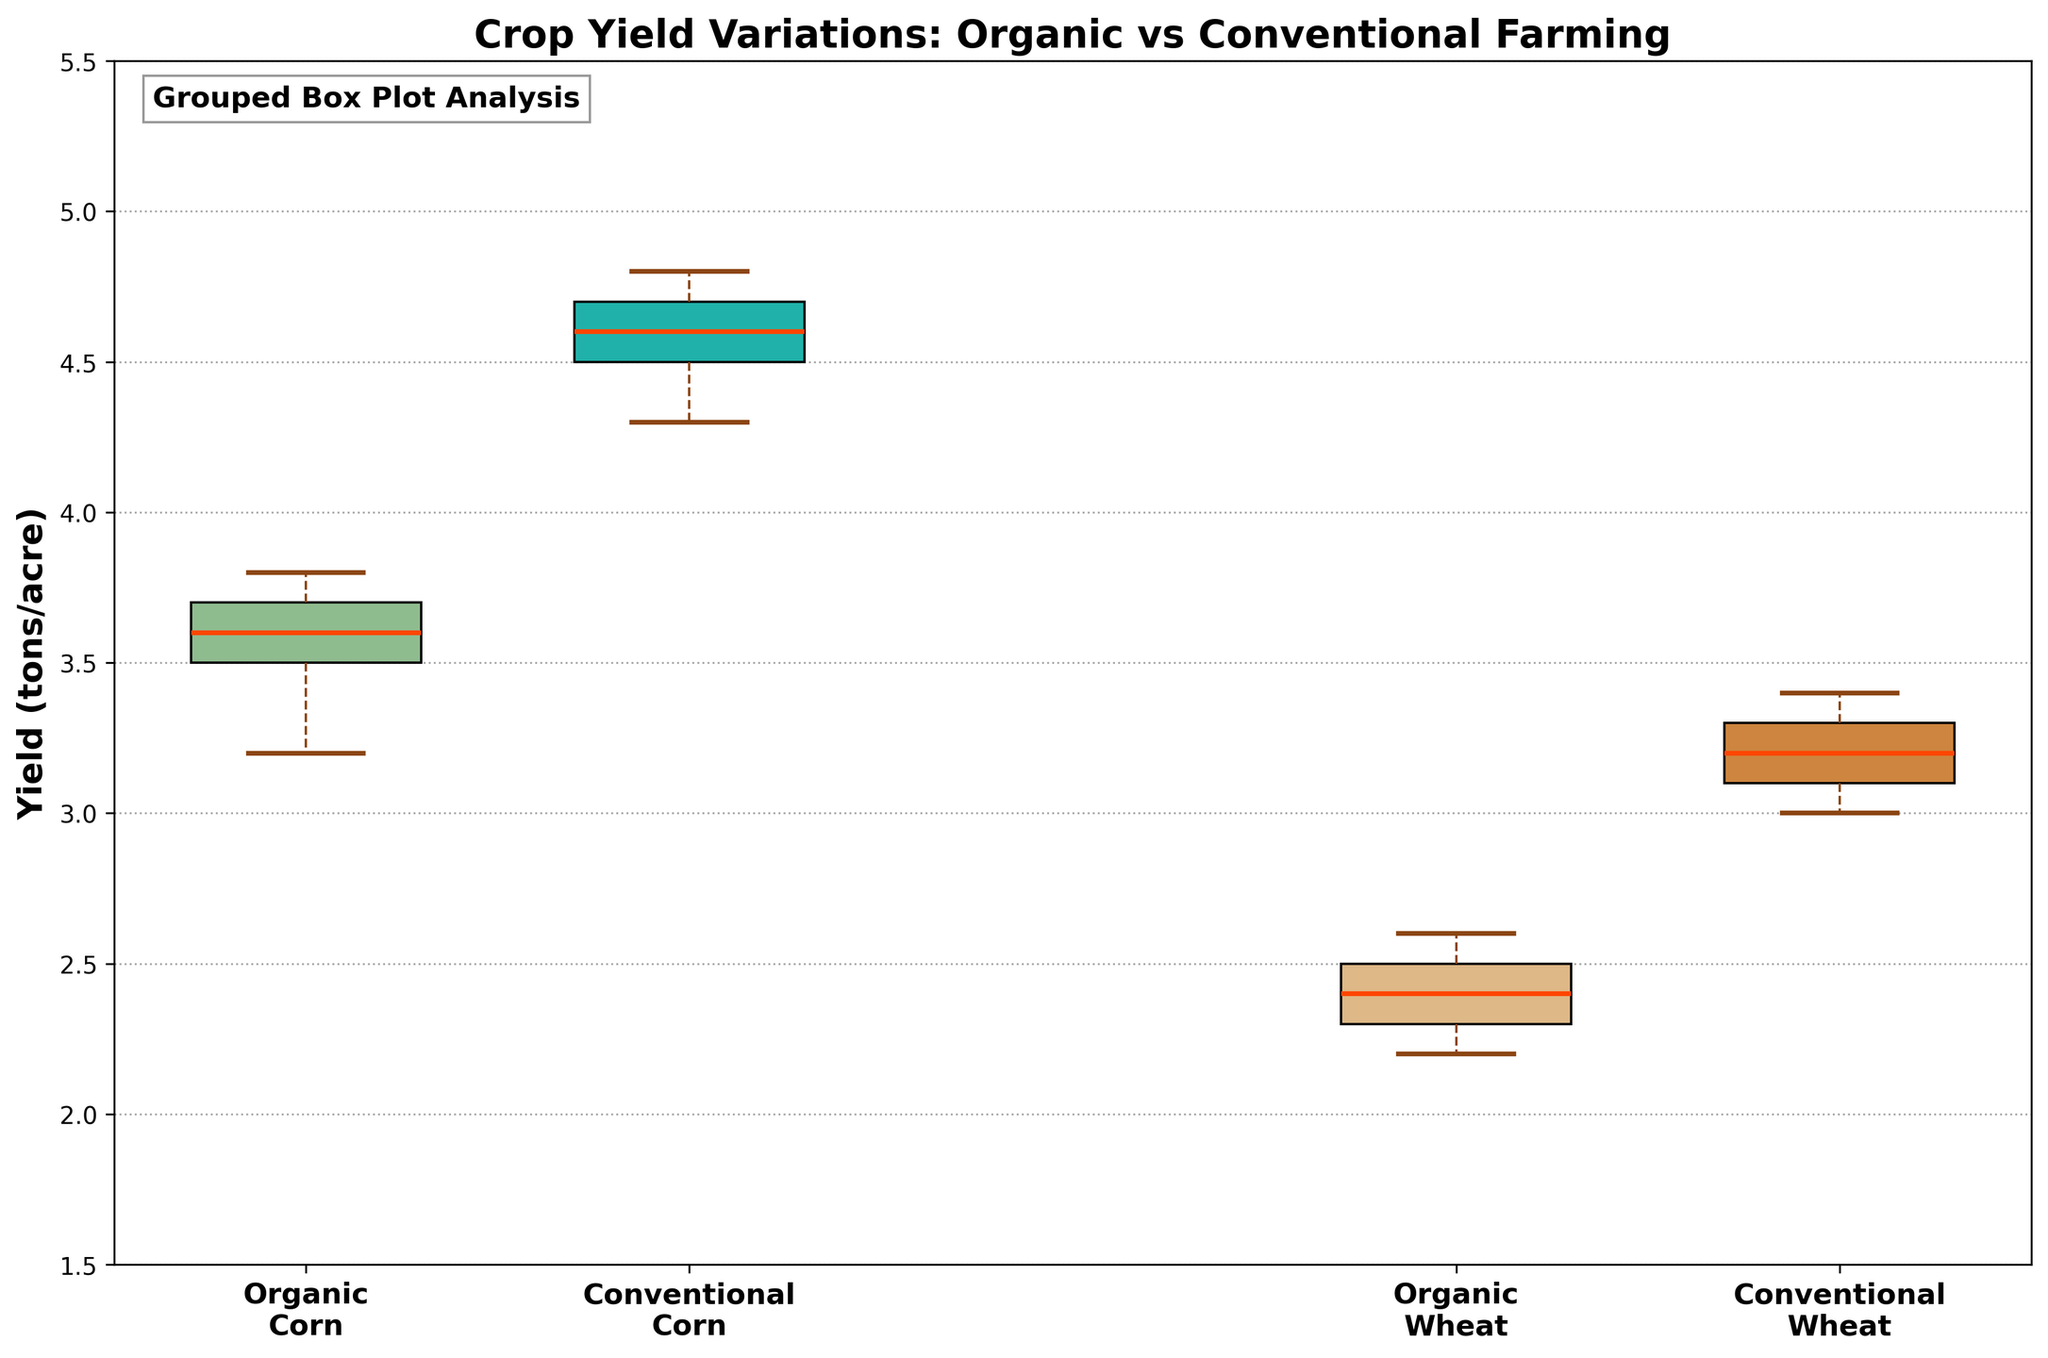What is the title of the plot? The title of the plot is often found at the top of the figure, providing a summary of the visualized data. In this case, the title says, "Crop Yield Variations: Organic vs Conventional Farming".
Answer: Crop Yield Variations: Organic vs Conventional Farming Which farming practice shows a higher median yield for Corn? To determine which farming practice has a higher median yield for Corn, look at the position of the median line within the box plots for "Organic Corn" and "Conventional Corn". The median line for Conventional Corn is higher than that for Organic Corn, indicating a higher yield.
Answer: Conventional What are the labels for the x-axis categories? The x-axis categories are labeled with the types of crops and the farming practices. The labels are 'Organic Corn', 'Conventional Corn', 'Organic Wheat', and 'Conventional Wheat'.
Answer: Organic Corn, Conventional Corn, Organic Wheat, Conventional Wheat Which crop and practice combination has the lowest yield value? To find the lowest yield value, check the lower end of the whiskers for each box plot. The lowest value occurs for Organic Wheat, as its whisker extends to the lowest point on the yield axis.
Answer: Organic Wheat Is there a difference in median yield between Organic Wheat and Conventional Wheat, and if so, how much? The median yield for Organic Wheat can be seen as the horizontal line inside the Organic Wheat box, and similarly for Conventional Wheat. By comparing these positions, the difference between the median yields of Organic and Conventional Wheat can be observed as approximately 1.0 tons/acre, given Organic Wheat's median is around 2.4 while Conventional Wheat's median is around 3.4.
Answer: 1.0 tons/acre Which group, among the four categories, shows the greatest range in yield values? The range of each group is the difference between the top of the upper whisker and the bottom of the lower whisker. By visually comparing these, Conventional Corn shows the greatest range as its whiskers span the largest distance on the y-axis.
Answer: Conventional Corn How does the consistency of yield for Organic Corn compare to Conventional Corn? Consistency can be assessed by looking at the interquartile range (IQR) which is represented by the height of the box. Organic Corn has a smaller IQR compared to Conventional Corn, indicating that Organic Corn yields are more consistent.
Answer: More consistent What patches colors are used to differentiate the farming practices of Corn and Wheat? The colors of the patches indicate different farming practices and crops. For Organic Corn, the box is greenish, and for Conventional Corn, it is teal. For Organic Wheat, the box is light brown, and for Conventional Wheat, it is darker brown.
Answer: Greenish, teal, light brown, darker brown Between Organic and Conventional practices, which one generally yields higher crop production? To determine which farming practice generally yields higher production, compare the median lines across both types of crops. Conventional practices consistently show higher median yields than Organic practices for both Corn and Wheat.
Answer: Conventional 